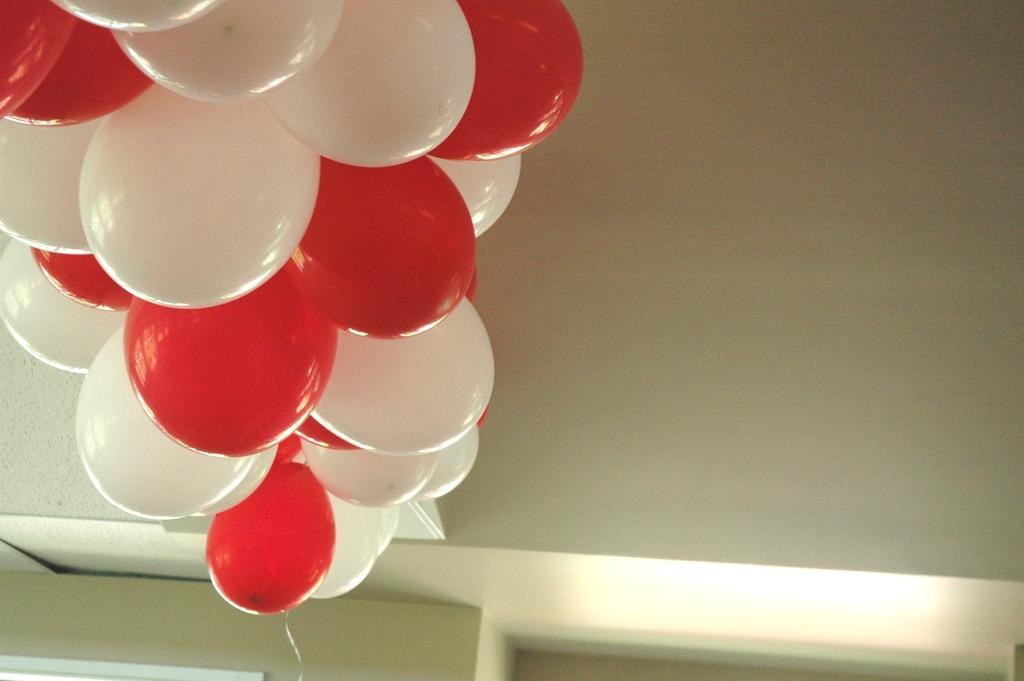Please provide a concise description of this image. In the image there are red and white colored balloons on the wall. At the bottom of the image there is wall with light. 